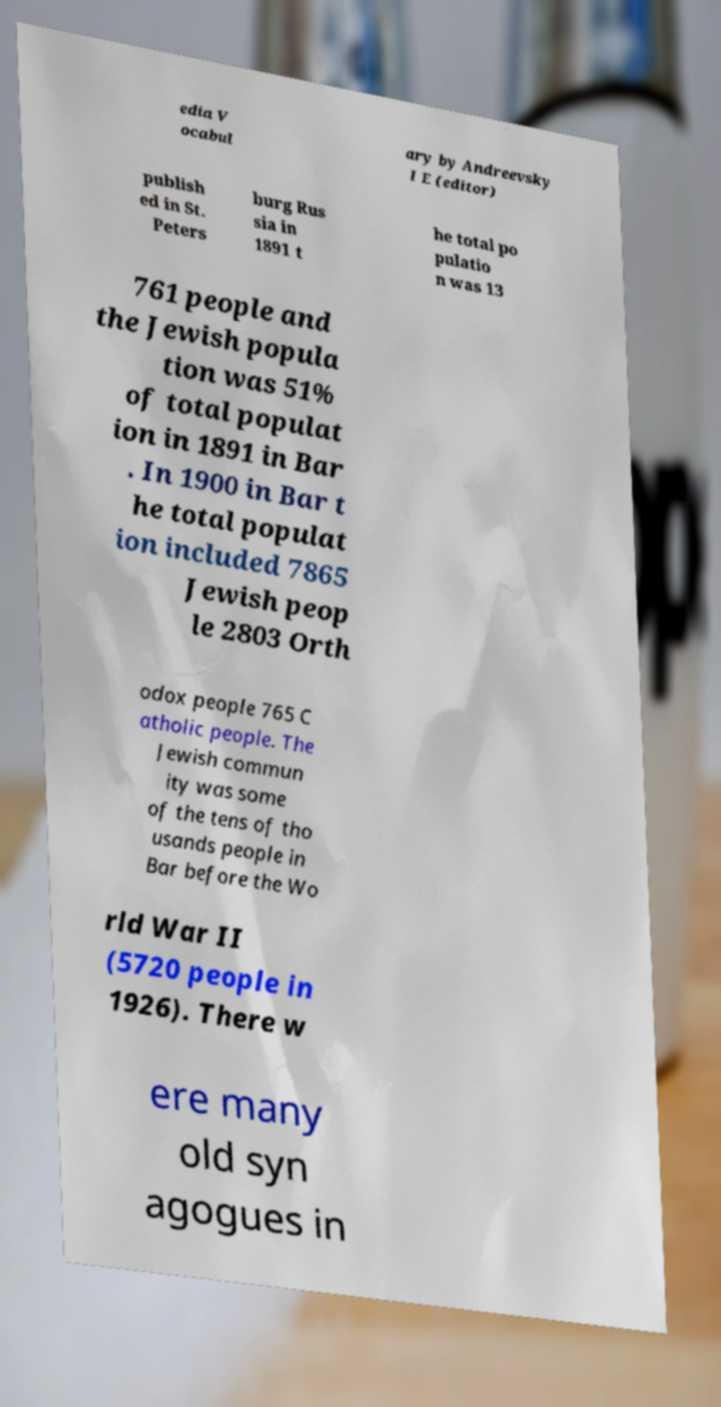What messages or text are displayed in this image? I need them in a readable, typed format. edia V ocabul ary by Andreevsky I E (editor) publish ed in St. Peters burg Rus sia in 1891 t he total po pulatio n was 13 761 people and the Jewish popula tion was 51% of total populat ion in 1891 in Bar . In 1900 in Bar t he total populat ion included 7865 Jewish peop le 2803 Orth odox people 765 C atholic people. The Jewish commun ity was some of the tens of tho usands people in Bar before the Wo rld War II (5720 people in 1926). There w ere many old syn agogues in 